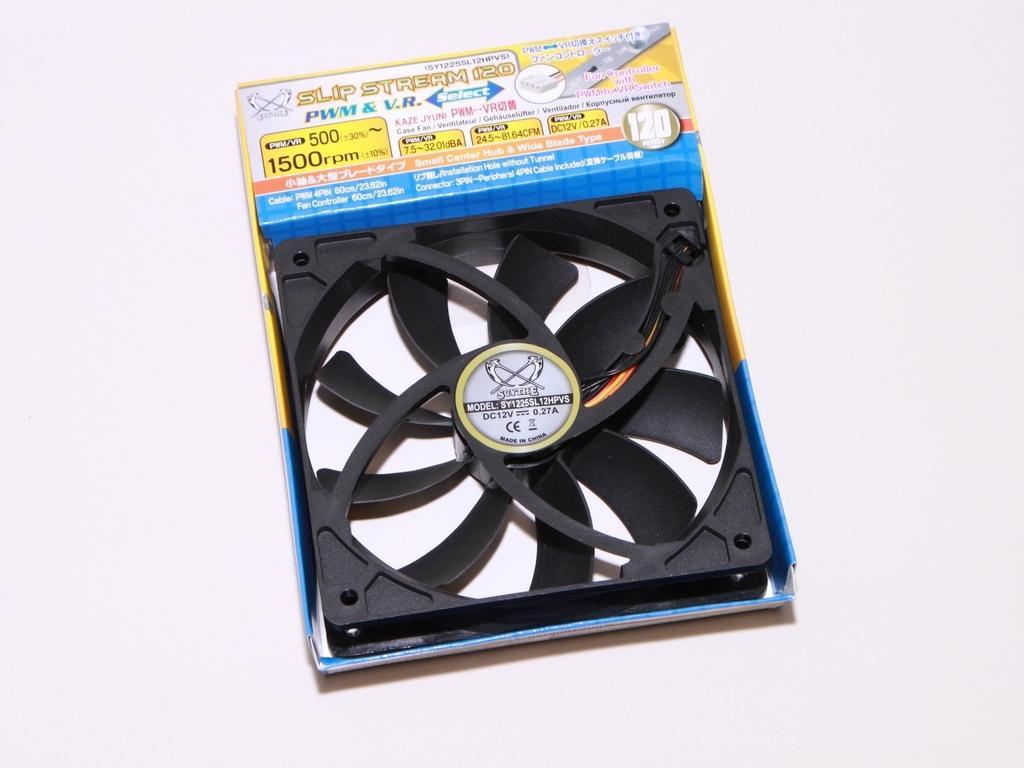Can you describe this image briefly? In this picture, it looks like an exhaust fan in the box and the box is on the white object. 